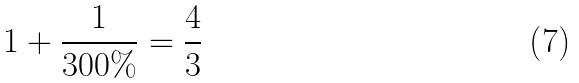Convert formula to latex. <formula><loc_0><loc_0><loc_500><loc_500>1 + \frac { 1 } { 3 0 0 \% } = \frac { 4 } { 3 }</formula> 